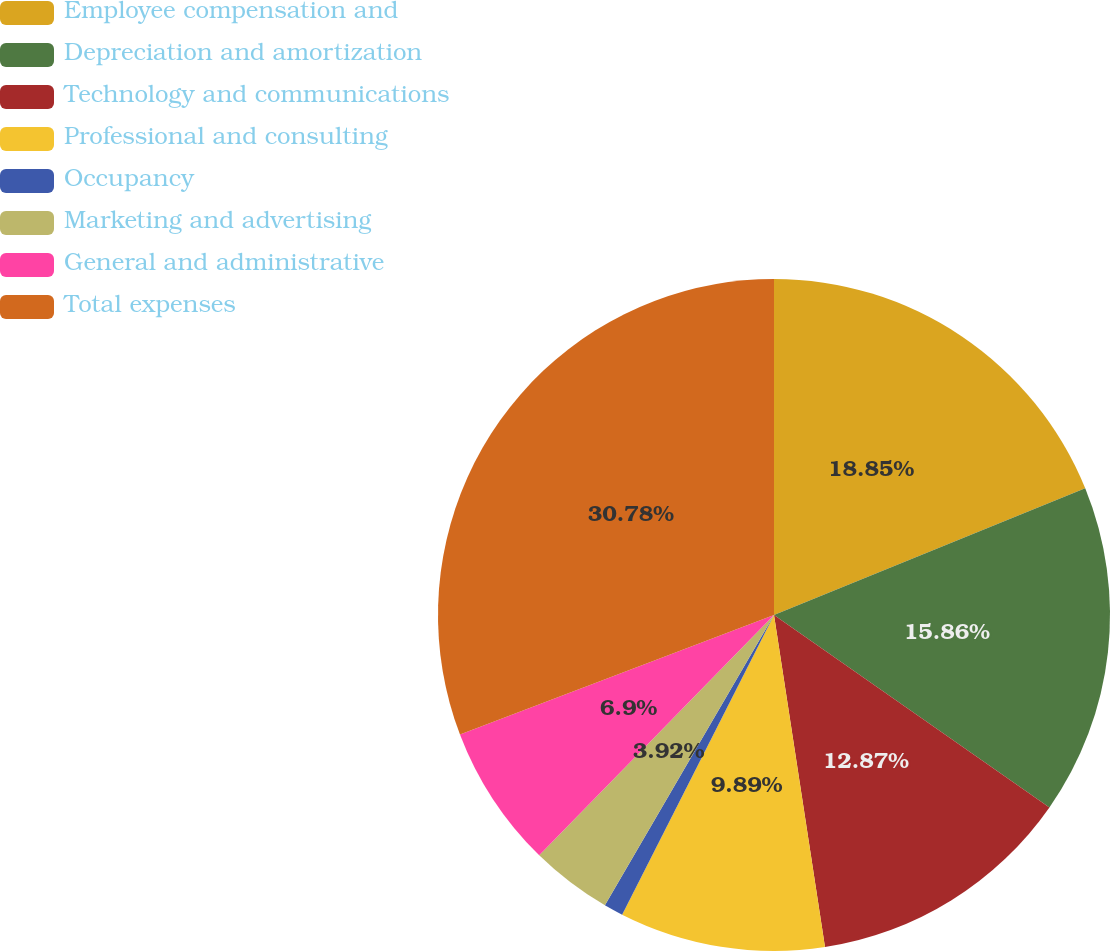Convert chart to OTSL. <chart><loc_0><loc_0><loc_500><loc_500><pie_chart><fcel>Employee compensation and<fcel>Depreciation and amortization<fcel>Technology and communications<fcel>Professional and consulting<fcel>Occupancy<fcel>Marketing and advertising<fcel>General and administrative<fcel>Total expenses<nl><fcel>18.85%<fcel>15.86%<fcel>12.87%<fcel>9.89%<fcel>0.93%<fcel>3.92%<fcel>6.9%<fcel>30.79%<nl></chart> 